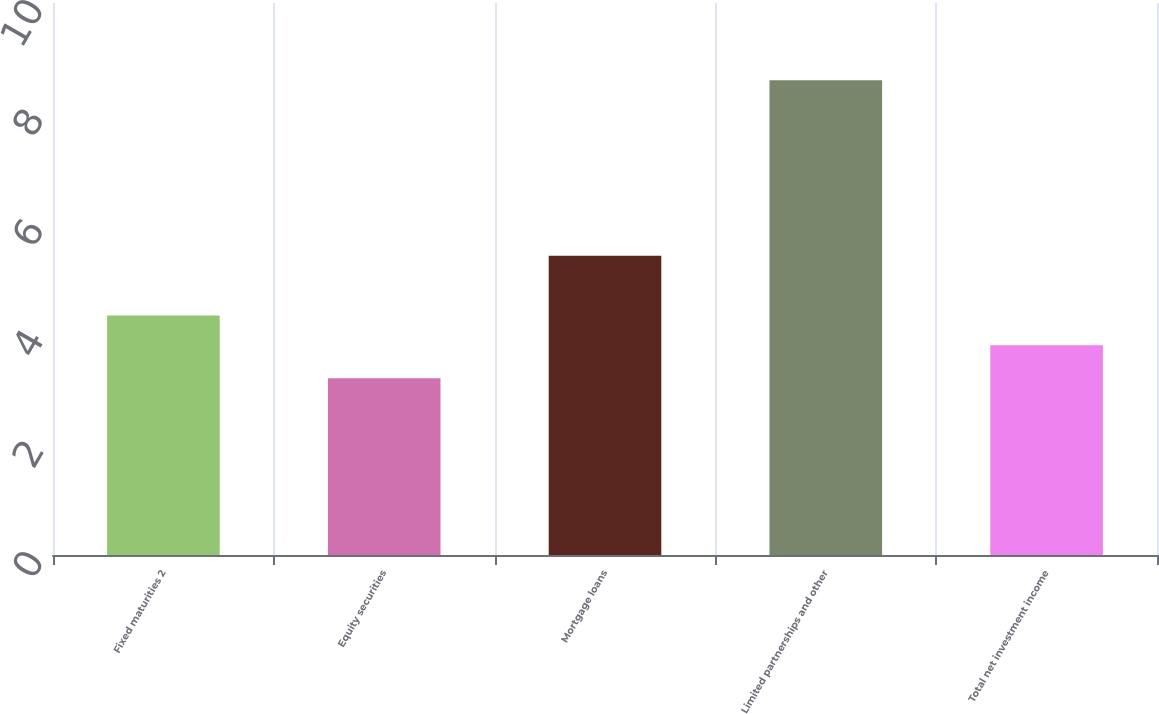<chart> <loc_0><loc_0><loc_500><loc_500><bar_chart><fcel>Fixed maturities 2<fcel>Equity securities<fcel>Mortgage loans<fcel>Limited partnerships and other<fcel>Total net investment income<nl><fcel>4.34<fcel>3.2<fcel>5.42<fcel>8.6<fcel>3.8<nl></chart> 